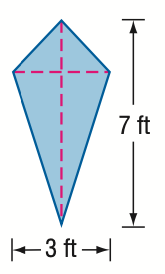Answer the mathemtical geometry problem and directly provide the correct option letter.
Question: Find the area of the kite.
Choices: A: 5.25 B: 10 C: 10.5 D: 21 C 